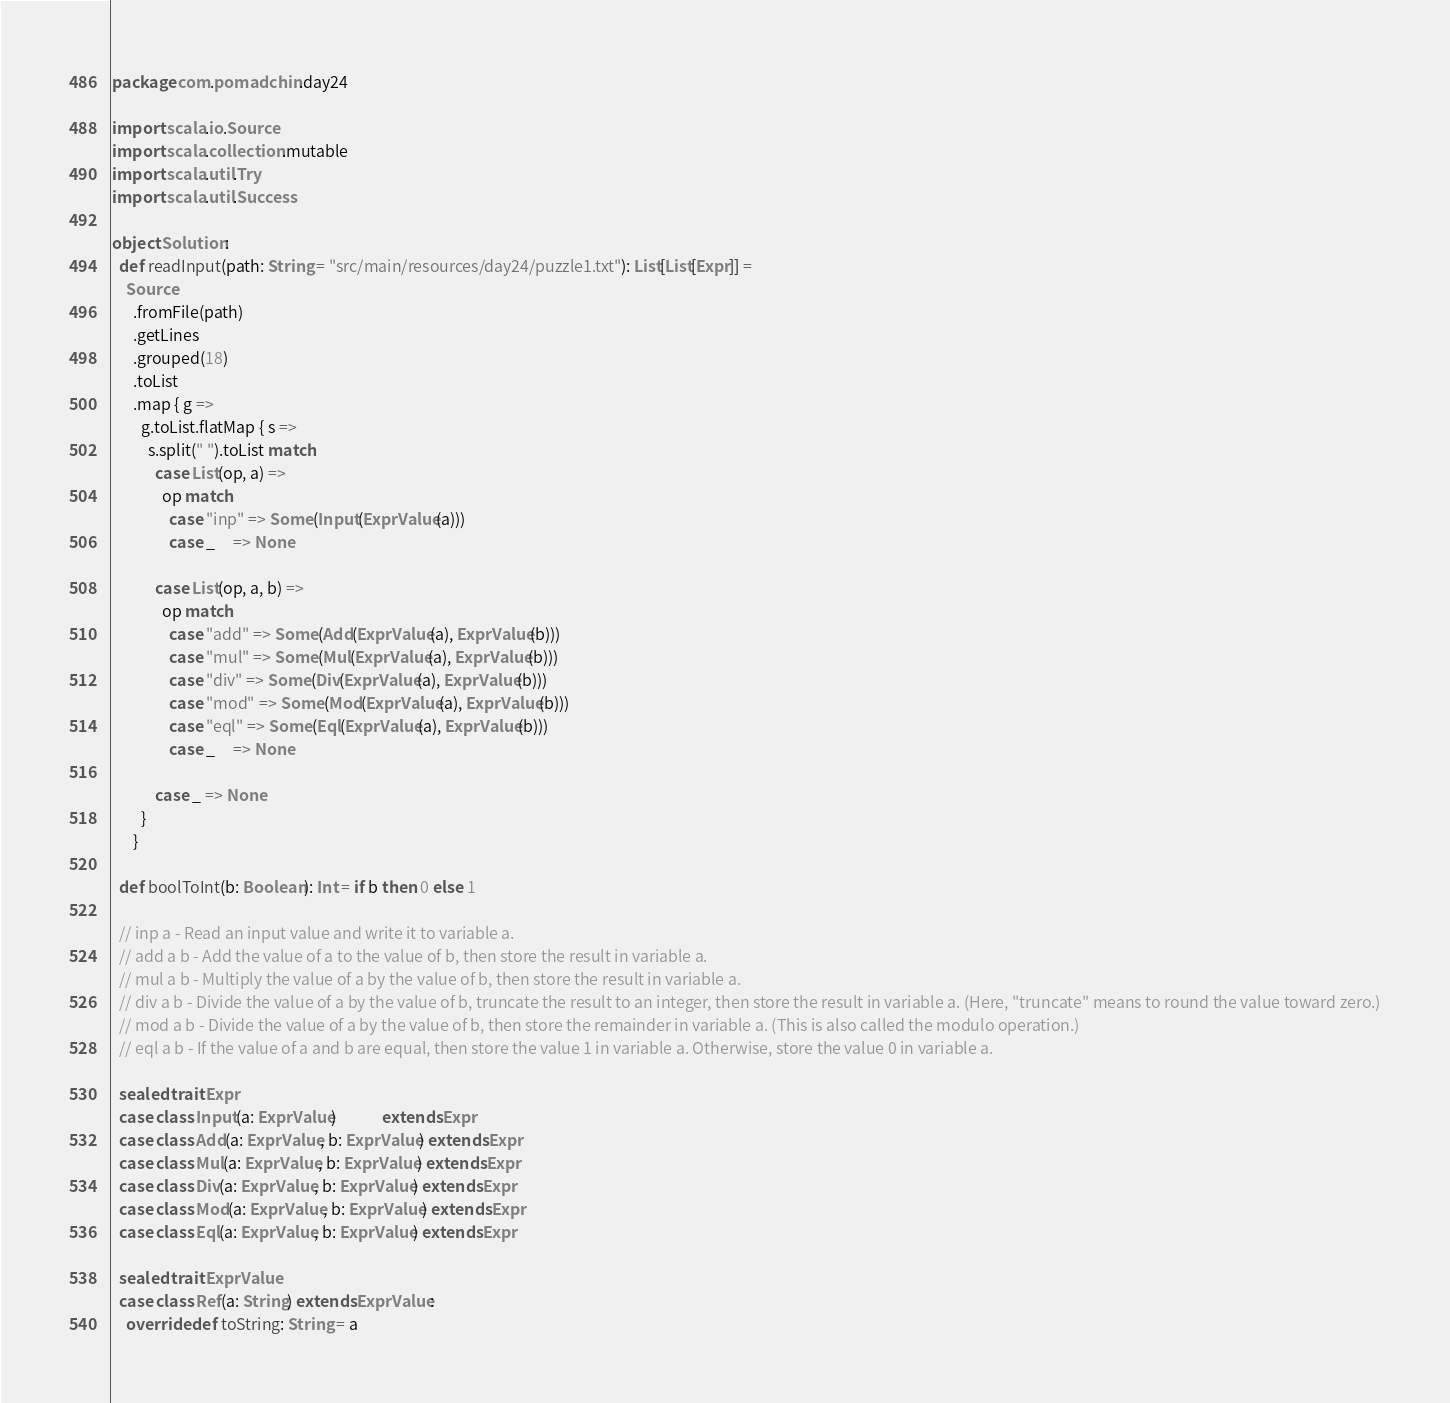Convert code to text. <code><loc_0><loc_0><loc_500><loc_500><_Scala_>package com.pomadchin.day24

import scala.io.Source
import scala.collection.mutable
import scala.util.Try
import scala.util.Success

object Solution:
  def readInput(path: String = "src/main/resources/day24/puzzle1.txt"): List[List[Expr]] =
    Source
      .fromFile(path)
      .getLines
      .grouped(18)
      .toList
      .map { g =>
        g.toList.flatMap { s =>
          s.split(" ").toList match
            case List(op, a) =>
              op match
                case "inp" => Some(Input(ExprValue(a)))
                case _     => None

            case List(op, a, b) =>
              op match
                case "add" => Some(Add(ExprValue(a), ExprValue(b)))
                case "mul" => Some(Mul(ExprValue(a), ExprValue(b)))
                case "div" => Some(Div(ExprValue(a), ExprValue(b)))
                case "mod" => Some(Mod(ExprValue(a), ExprValue(b)))
                case "eql" => Some(Eql(ExprValue(a), ExprValue(b)))
                case _     => None

            case _ => None
        }
      }

  def boolToInt(b: Boolean): Int = if b then 0 else 1

  // inp a - Read an input value and write it to variable a.
  // add a b - Add the value of a to the value of b, then store the result in variable a.
  // mul a b - Multiply the value of a by the value of b, then store the result in variable a.
  // div a b - Divide the value of a by the value of b, truncate the result to an integer, then store the result in variable a. (Here, "truncate" means to round the value toward zero.)
  // mod a b - Divide the value of a by the value of b, then store the remainder in variable a. (This is also called the modulo operation.)
  // eql a b - If the value of a and b are equal, then store the value 1 in variable a. Otherwise, store the value 0 in variable a.

  sealed trait Expr
  case class Input(a: ExprValue)             extends Expr
  case class Add(a: ExprValue, b: ExprValue) extends Expr
  case class Mul(a: ExprValue, b: ExprValue) extends Expr
  case class Div(a: ExprValue, b: ExprValue) extends Expr
  case class Mod(a: ExprValue, b: ExprValue) extends Expr
  case class Eql(a: ExprValue, b: ExprValue) extends Expr

  sealed trait ExprValue
  case class Ref(a: String) extends ExprValue:
    override def toString: String = a</code> 